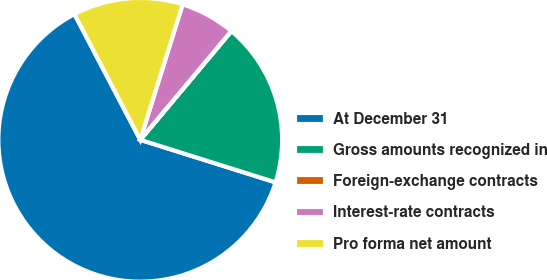Convert chart to OTSL. <chart><loc_0><loc_0><loc_500><loc_500><pie_chart><fcel>At December 31<fcel>Gross amounts recognized in<fcel>Foreign-exchange contracts<fcel>Interest-rate contracts<fcel>Pro forma net amount<nl><fcel>62.47%<fcel>18.75%<fcel>0.01%<fcel>6.26%<fcel>12.5%<nl></chart> 